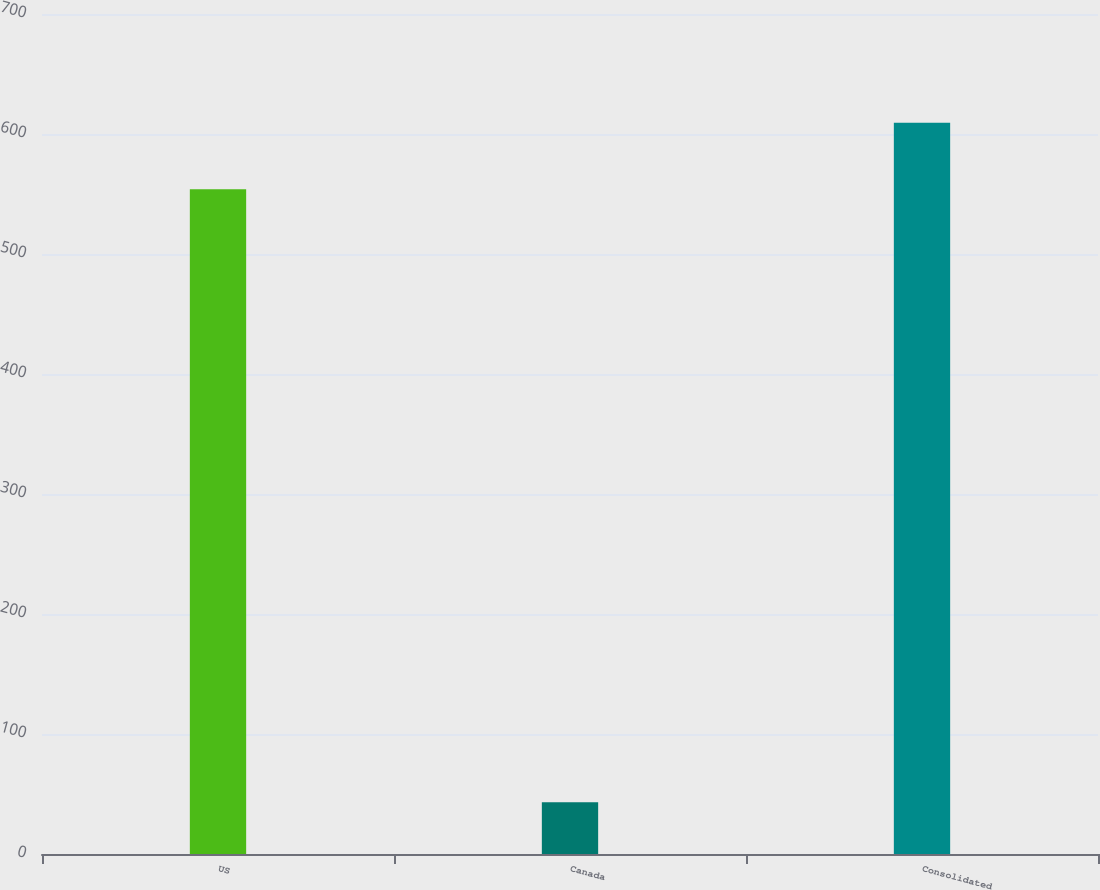<chart> <loc_0><loc_0><loc_500><loc_500><bar_chart><fcel>US<fcel>Canada<fcel>Consolidated<nl><fcel>553.9<fcel>43.1<fcel>609.29<nl></chart> 